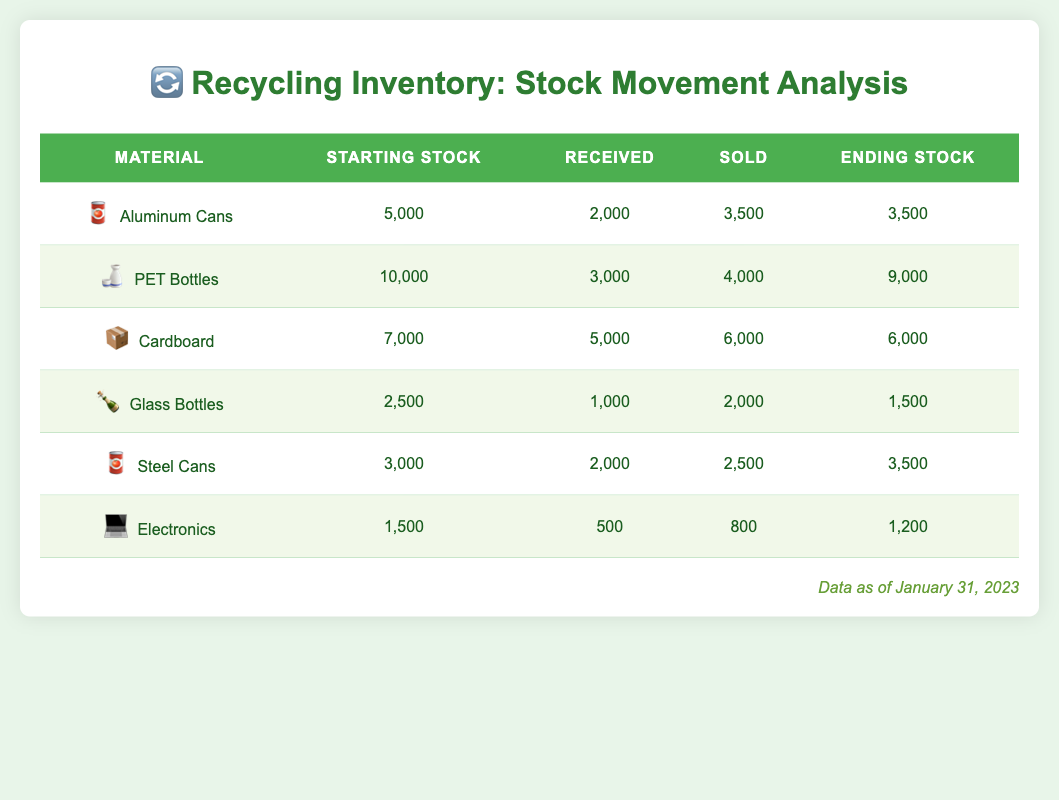What was the starting stock of Aluminum Cans? The starting stock for Aluminum Cans is listed in the table under the "Starting Stock" column for that material. According to the table, it shows 5,000.
Answer: 5,000 What is the ending stock of Glass Bottles? To find the ending stock of Glass Bottles, we refer to the table under the "Ending Stock" column for that material. It is listed as 1,500.
Answer: 1,500 How many PET Bottles were sold? The number of PET Bottles sold can be found in the "Sold" column specific to that material. The table indicates that 4,000 PET Bottles were sold.
Answer: 4,000 What is the total quantity of materials received? To calculate the total quantity of materials received, we need to sum the values in the "Received" column: 2,000 (Aluminum Cans) + 3,000 (PET Bottles) + 5,000 (Cardboard) + 1,000 (Glass Bottles) + 2,000 (Steel Cans) + 500 (Electronics) = 13,500.
Answer: 13,500 Did Steel Cans end with less stock than they started? We compare the "Starting Stock" (3,000) and "Ending Stock" (3,500) for Steel Cans in the table. Since 3,500 is greater than 3,000, the statement is false.
Answer: No Which material had the highest ending stock? To determine which material had the highest ending stock, we can compare the "Ending Stock" values in the table: 3,500 (Aluminum Cans), 9,000 (PET Bottles), 6,000 (Cardboard), 1,500 (Glass Bottles), 3,500 (Steel Cans), and 1,200 (Electronics). The highest value is 9,000 from PET Bottles.
Answer: PET Bottles What is the difference in stock sold between Cardboard and Electronics? We calculate the difference by subtracting the "Sold" quantity of Electronics (800) from the "Sold" quantity of Cardboard (6,000): 6,000 - 800 = 5,200.
Answer: 5,200 Is the amount of Aluminum Cans received greater than that of Glass Bottles? To answer this, we look at the "Received" column: Aluminum Cans received 2,000 while Glass Bottles received 1,000. Since 2,000 is greater than 1,000, the statement is true.
Answer: Yes What was the average stock sold across all materials? We find the average stock sold by summing up the "Sold" column: 3,500 + 4,000 + 6,000 + 2,000 + 2,500 + 800 = 18,800. Then, we divide by the number of materials (6) to get the average: 18,800 / 6 = 3,133.33 (rounded to two decimal places).
Answer: 3,133.33 